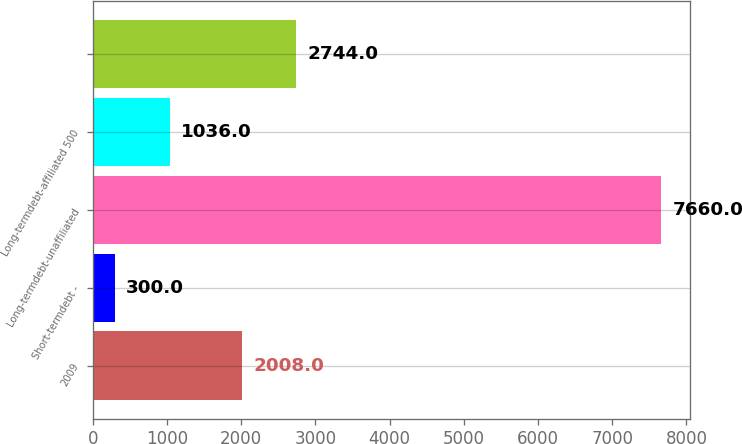<chart> <loc_0><loc_0><loc_500><loc_500><bar_chart><fcel>2009<fcel>Short-termdebt -<fcel>Long-termdebt-unaffiliated<fcel>Long-termdebt-affiliated 500<fcel>Unnamed: 4<nl><fcel>2008<fcel>300<fcel>7660<fcel>1036<fcel>2744<nl></chart> 